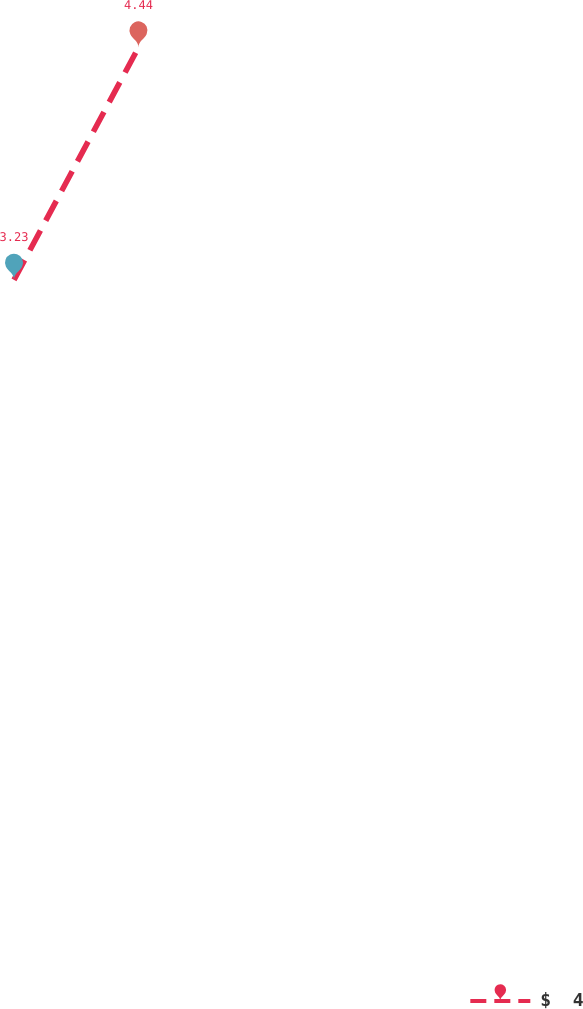Convert chart to OTSL. <chart><loc_0><loc_0><loc_500><loc_500><line_chart><ecel><fcel>$  4<nl><fcel>1792.13<fcel>3.23<nl><fcel>1843.31<fcel>4.44<nl><fcel>2267.23<fcel>4.57<nl><fcel>2318.41<fcel>4.31<nl></chart> 